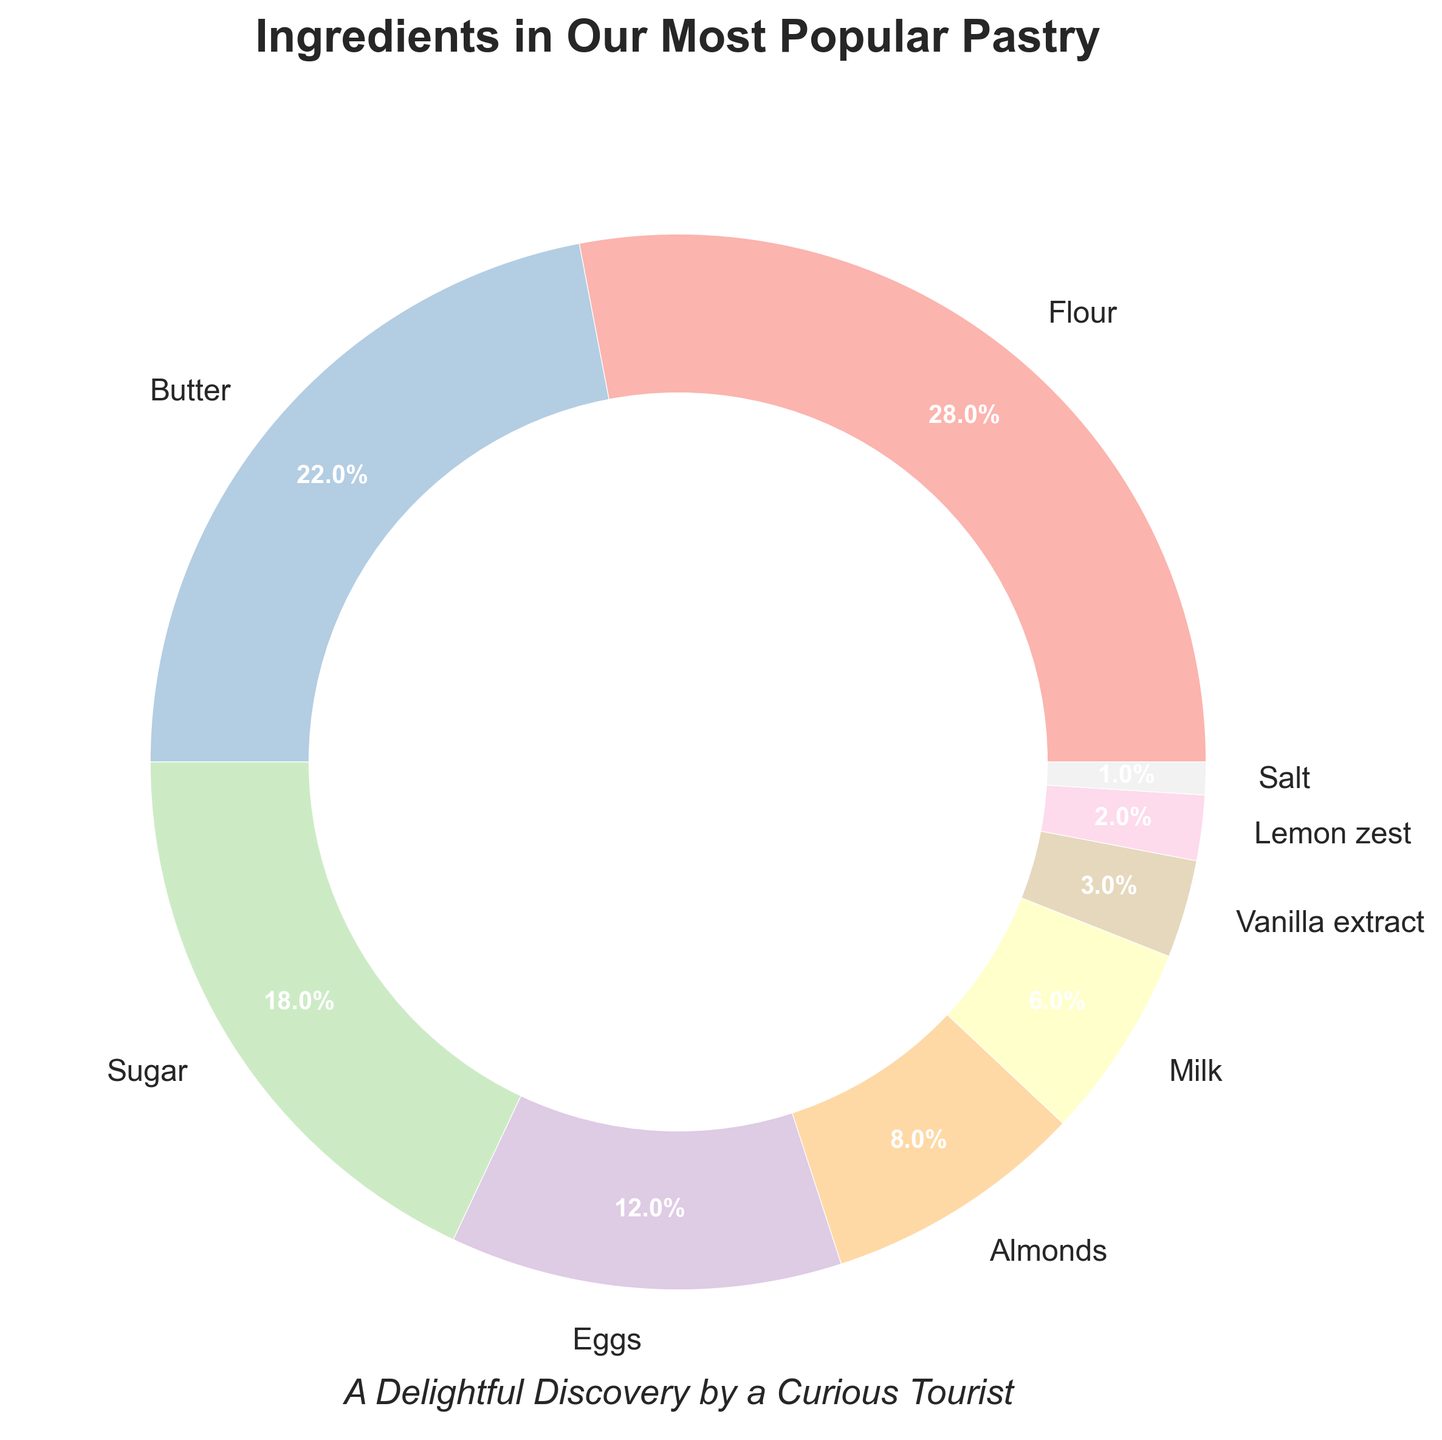What is the largest ingredient percentage in the pastry? The pie chart shows the different ingredients and their corresponding percentages. By visually identifying the largest wedge, we can see that it represents Flour with 28%.
Answer: Flour, 28% Which ingredient has a higher percentage, Sugar or Butter? To answer this, we need to compare the wedges for Sugar and Butter. The chart shows Sugar at 18% and Butter at 22%, so Butter has a higher percentage.
Answer: Butter What is the total percentage of Flour and Sugar combined? To find the total percentage of Flour and Sugar, we sum their individual percentages: Flour is 28% and Sugar is 18%. Adding these together gives 28% + 18% = 46%.
Answer: 46% How much more percentage does Butter have than Eggs? Comparing the percentages visually, Butter has 22% and Eggs have 12%. Subtracting these gives 22% - 12% = 10%.
Answer: 10% What is the difference in percentage between the ingredient with the smallest and the largest proportions? The smallest percentage is Salt at 1%, and the largest is Flour at 28%. Subtracting these gives 28% - 1% = 27%.
Answer: 27% Which ingredient uses the least percentage in the recipe, and what is it? By identifying the smallest wedge in the pie chart, we can see that Salt has the smallest percentage at 1%.
Answer: Salt, 1% If we combine the percentage values for Vanilla extract, Lemon zest, and Salt, what is their total? Adding the values for Vanilla extract (3%), Lemon zest (2%), and Salt (1%) gives us 3% + 2% + 1% = 6%.
Answer: 6% Among Milk, Almonds, and Eggs, which one has the lowest percentage? By examining the pie chart, we can see that Milk has 6%, Almonds have 8%, and Eggs have 12%. Hence, Milk has the lowest percentage among these three.
Answer: Milk If you remove the percentage for Flour, what is the new total percentage for the remaining ingredients? The total percentage for all ingredients is 100%. Removing Flour's 28% gives 100% - 28% = 72%.
Answer: 72% What is the average percentage of Butter, Sugar, Eggs, and Almonds? Adding the percentages for Butter (22%), Sugar (18%), Eggs (12%), and Almonds (8%), we get 22% + 18% + 12% + 8% = 60%. Dividing 60% by 4 gives an average of 60% / 4 = 15%.
Answer: 15% 